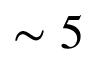<formula> <loc_0><loc_0><loc_500><loc_500>\sim 5</formula> 